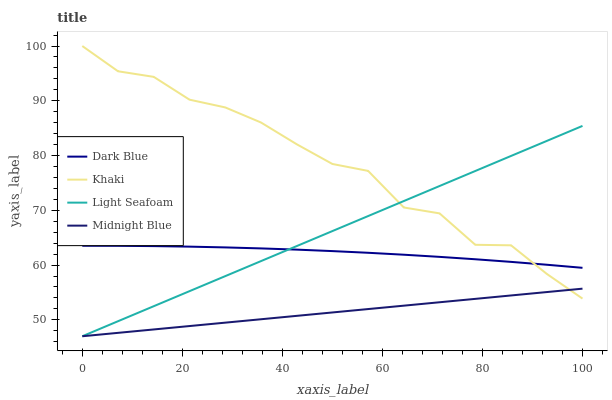Does Midnight Blue have the minimum area under the curve?
Answer yes or no. Yes. Does Khaki have the maximum area under the curve?
Answer yes or no. Yes. Does Khaki have the minimum area under the curve?
Answer yes or no. No. Does Midnight Blue have the maximum area under the curve?
Answer yes or no. No. Is Midnight Blue the smoothest?
Answer yes or no. Yes. Is Khaki the roughest?
Answer yes or no. Yes. Is Khaki the smoothest?
Answer yes or no. No. Is Midnight Blue the roughest?
Answer yes or no. No. Does Khaki have the lowest value?
Answer yes or no. No. Does Khaki have the highest value?
Answer yes or no. Yes. Does Midnight Blue have the highest value?
Answer yes or no. No. Is Midnight Blue less than Dark Blue?
Answer yes or no. Yes. Is Dark Blue greater than Midnight Blue?
Answer yes or no. Yes. Does Midnight Blue intersect Light Seafoam?
Answer yes or no. Yes. Is Midnight Blue less than Light Seafoam?
Answer yes or no. No. Is Midnight Blue greater than Light Seafoam?
Answer yes or no. No. Does Midnight Blue intersect Dark Blue?
Answer yes or no. No. 